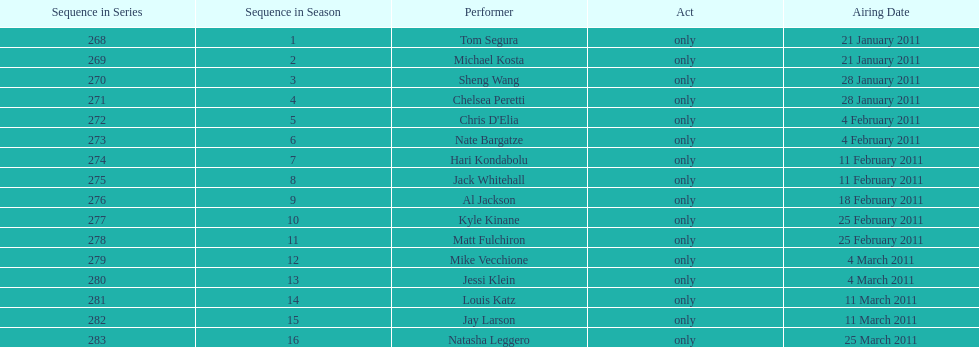Which month saw the greatest number of performers? February. 